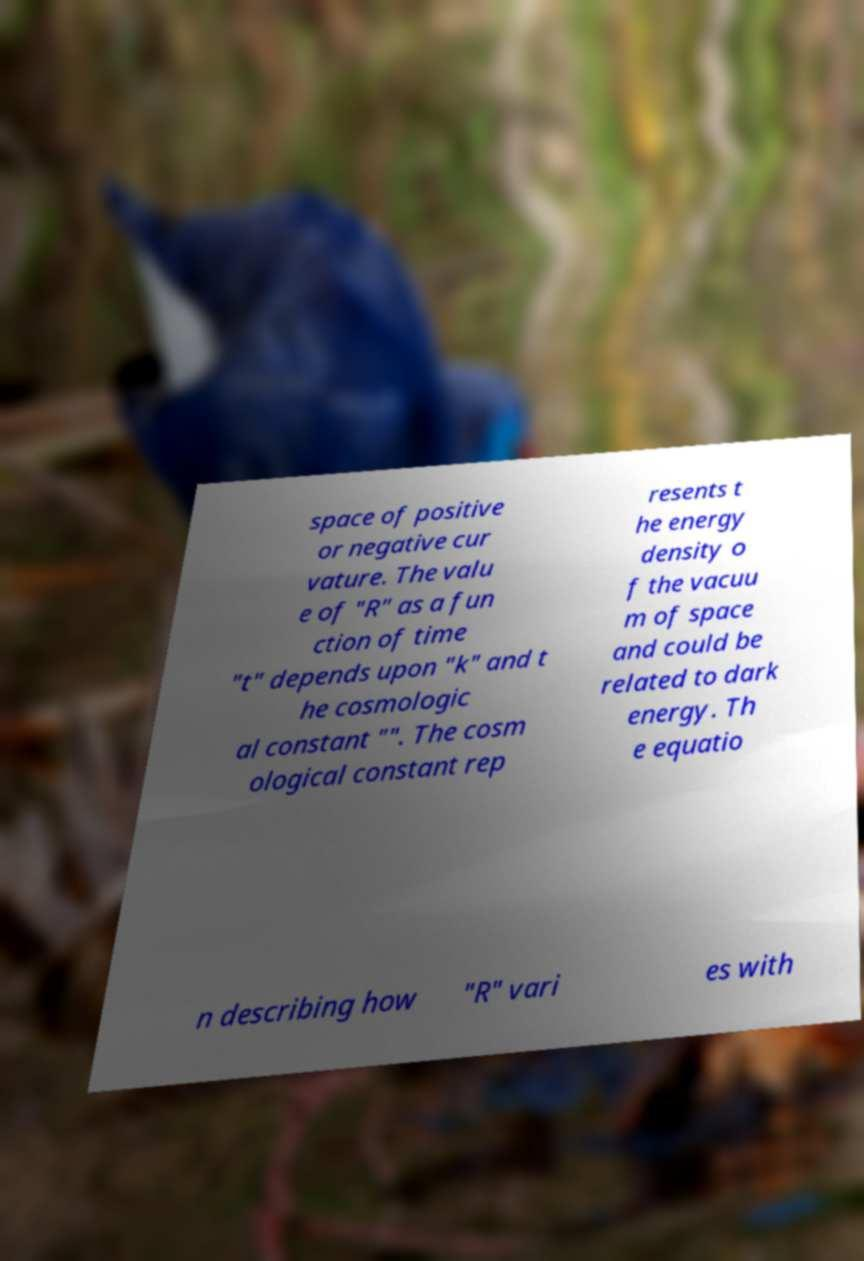Could you assist in decoding the text presented in this image and type it out clearly? space of positive or negative cur vature. The valu e of "R" as a fun ction of time "t" depends upon "k" and t he cosmologic al constant "". The cosm ological constant rep resents t he energy density o f the vacuu m of space and could be related to dark energy. Th e equatio n describing how "R" vari es with 